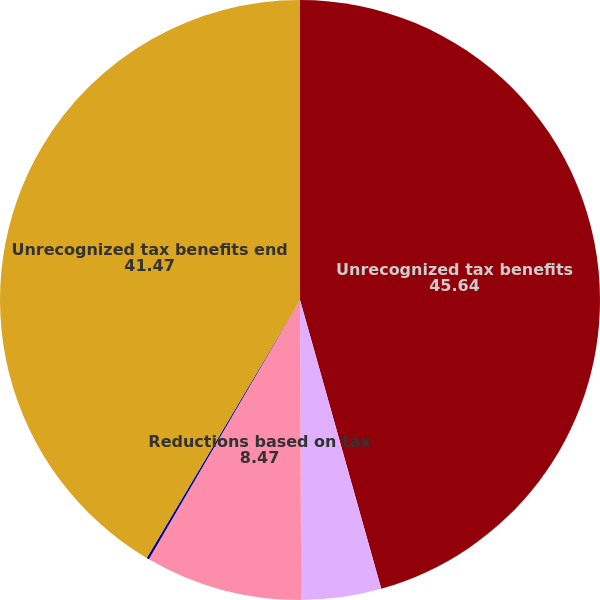<chart> <loc_0><loc_0><loc_500><loc_500><pie_chart><fcel>Unrecognized tax benefits<fcel>Additions based on tax<fcel>Reductions based on tax<fcel>Statute of limitations lapses<fcel>Unrecognized tax benefits end<nl><fcel>45.64%<fcel>4.3%<fcel>8.47%<fcel>0.13%<fcel>41.47%<nl></chart> 